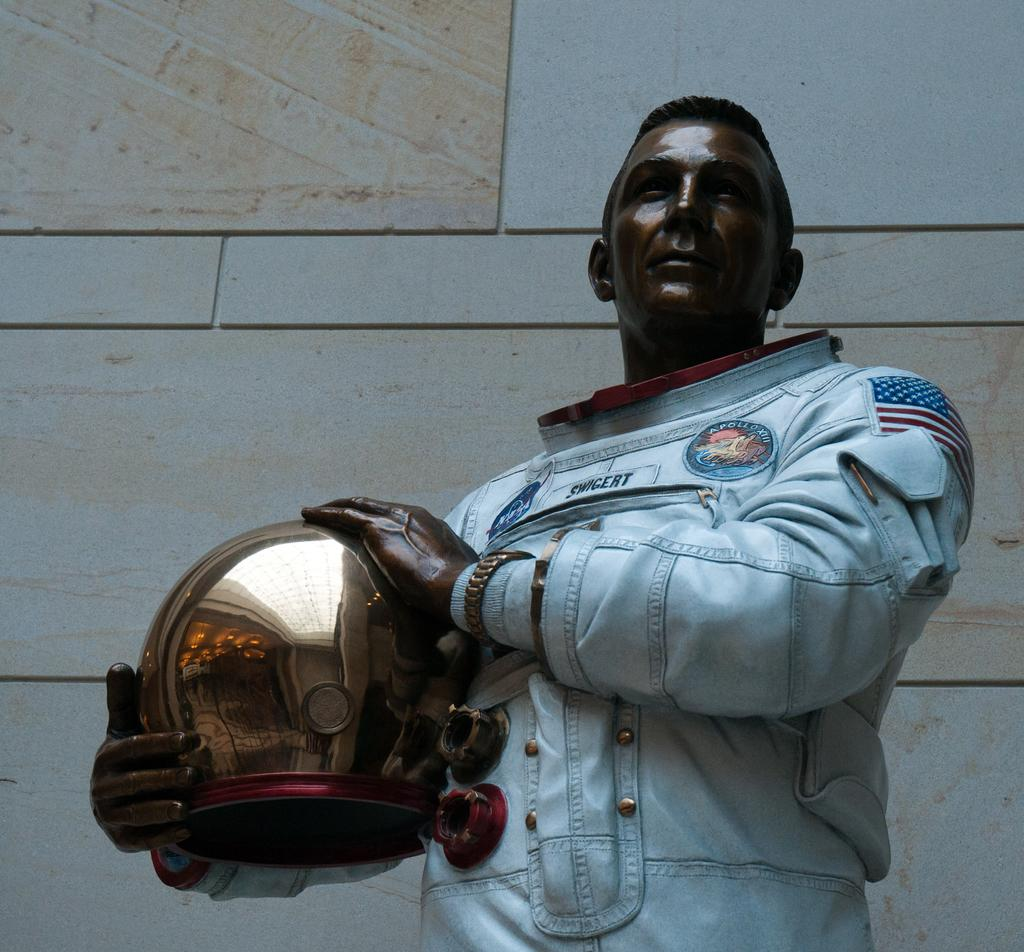What is the main subject of the image? There is a statue in the image. What can be seen on the left side of the image? There is a helmet on the left side of the image. What type of clothing is visible in the image? There is a blue jacket in the image. What is visible in the background of the image? There is a wall in the background of the image. What type of wren can be seen singing on the statue's shoulder in the image? There is no wren present in the image, and the statue does not have a shoulder. 